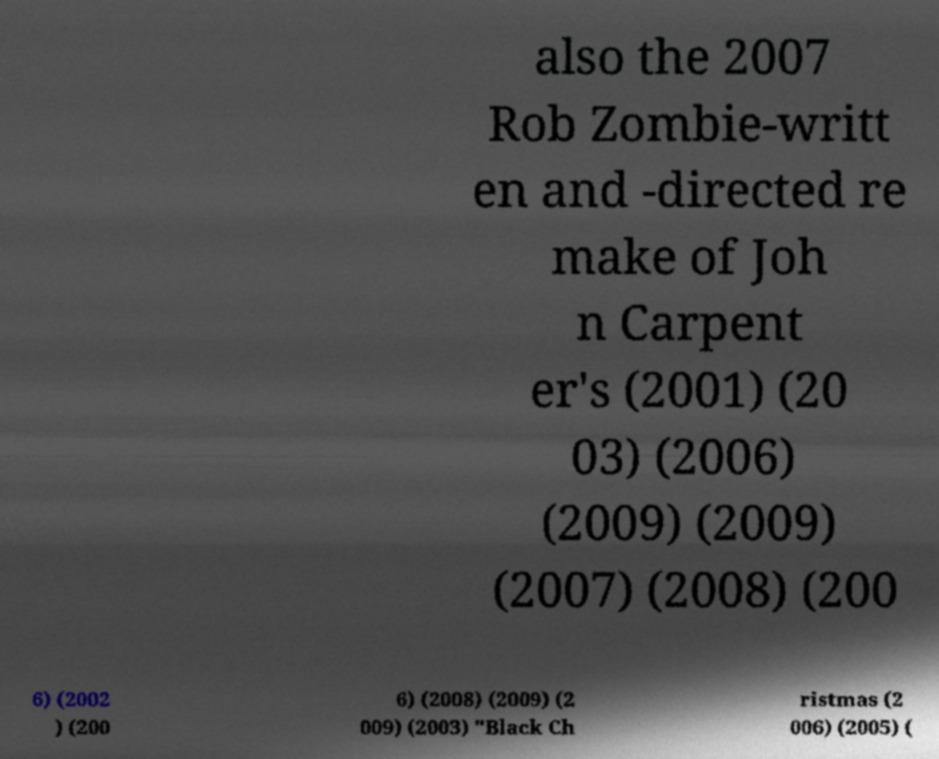Can you accurately transcribe the text from the provided image for me? also the 2007 Rob Zombie-writt en and -directed re make of Joh n Carpent er's (2001) (20 03) (2006) (2009) (2009) (2007) (2008) (200 6) (2002 ) (200 6) (2008) (2009) (2 009) (2003) "Black Ch ristmas (2 006) (2005) ( 